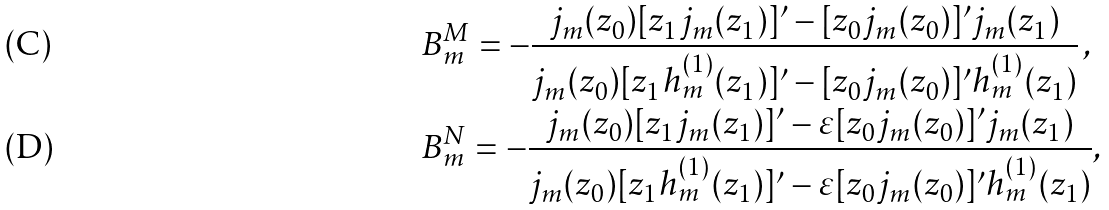Convert formula to latex. <formula><loc_0><loc_0><loc_500><loc_500>& B _ { m } ^ { M } = - \frac { j _ { m } ( z _ { 0 } ) [ z _ { 1 } j _ { m } ( z _ { 1 } ) ] ^ { \prime } - [ z _ { 0 } j _ { m } ( z _ { 0 } ) ] ^ { \prime } j _ { m } ( z _ { 1 } ) } { j _ { m } ( z _ { 0 } ) [ z _ { 1 } h _ { m } ^ { ( 1 ) } ( z _ { 1 } ) ] ^ { \prime } - [ z _ { 0 } j _ { m } ( z _ { 0 } ) ] ^ { \prime } h _ { m } ^ { ( 1 ) } ( z _ { 1 } ) } \, , \\ & B _ { m } ^ { N } = - \frac { j _ { m } ( z _ { 0 } ) [ z _ { 1 } j _ { m } ( z _ { 1 } ) ] ^ { \prime } - \varepsilon [ z _ { 0 } j _ { m } ( z _ { 0 } ) ] ^ { \prime } j _ { m } ( z _ { 1 } ) } { j _ { m } ( z _ { 0 } ) [ z _ { 1 } h _ { m } ^ { ( 1 ) } ( z _ { 1 } ) ] ^ { \prime } - \varepsilon [ z _ { 0 } j _ { m } ( z _ { 0 } ) ] ^ { \prime } h _ { m } ^ { ( 1 ) } ( z _ { 1 } ) } ,</formula> 